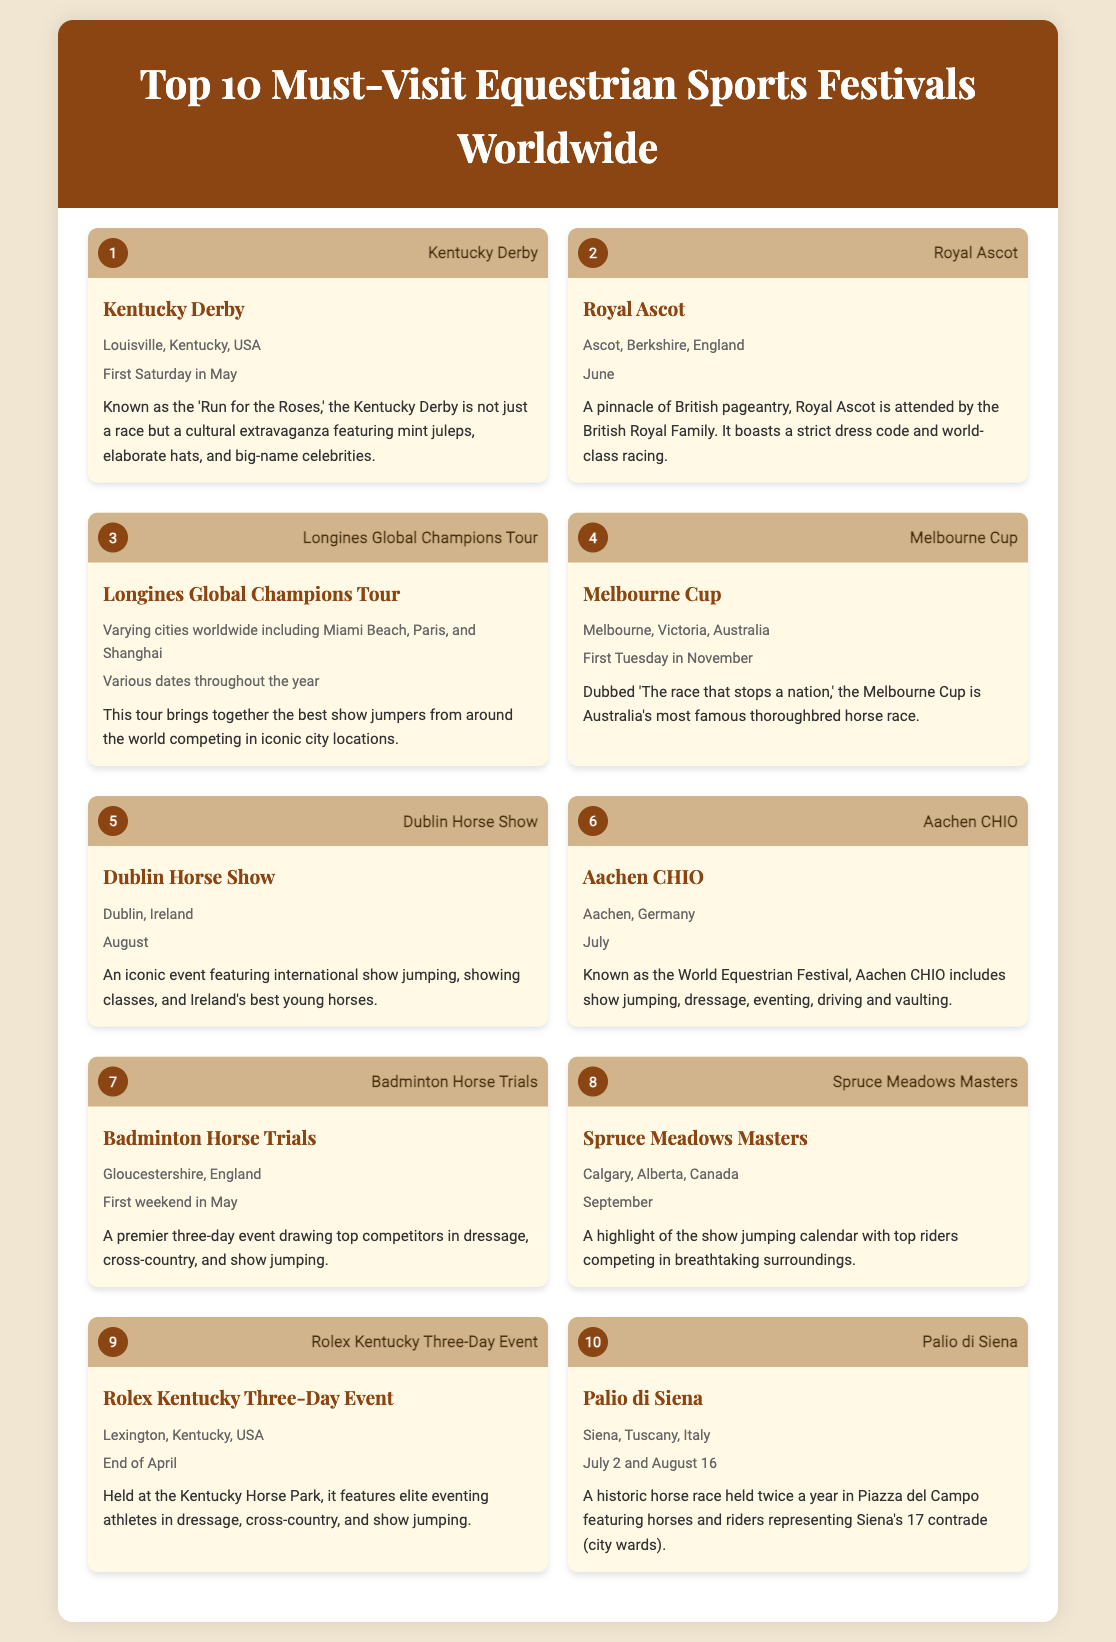What is the first festival listed? The document presents a ranked list of equestrian sports festivals where the first one mentioned is the Kentucky Derby.
Answer: Kentucky Derby What city hosts the Royal Ascot? The document specifies that the Royal Ascot takes place in Ascot, Berkshire, England.
Answer: Ascot, Berkshire, England When is the Melbourne Cup held? According to the document, the Melbourne Cup occurs on the first Tuesday in November.
Answer: First Tuesday in November Which festival is known as the 'Run for the Roses'? The document identifies the Kentucky Derby as being known by this nickname.
Answer: Kentucky Derby How many times a year is the Palio di Siena held? The festival occurs twice a year, as mentioned in the document.
Answer: Twice What is the location of the Spruce Meadows Masters? The document indicates that the Spruce Meadows Masters is located in Calgary, Alberta, Canada.
Answer: Calgary, Alberta, Canada What type of event is the Rolex Kentucky Three-Day Event? The document describes this event as an equestrian triathlon involving three disciplines: dressage, cross-country, and show jumping.
Answer: Eventing Which festival is referred to as 'The race that stops a nation'? The Melbourne Cup is recognized by this title in the document.
Answer: Melbourne Cup What rank is the Aachen CHIO in the list? The document states that Aachen CHIO is ranked 6th.
Answer: 6 What unique feature does the Dublin Horse Show highlight? The document notes that the Dublin Horse Show features international show jumping and showcasing Ireland's best young horses.
Answer: International show jumping 